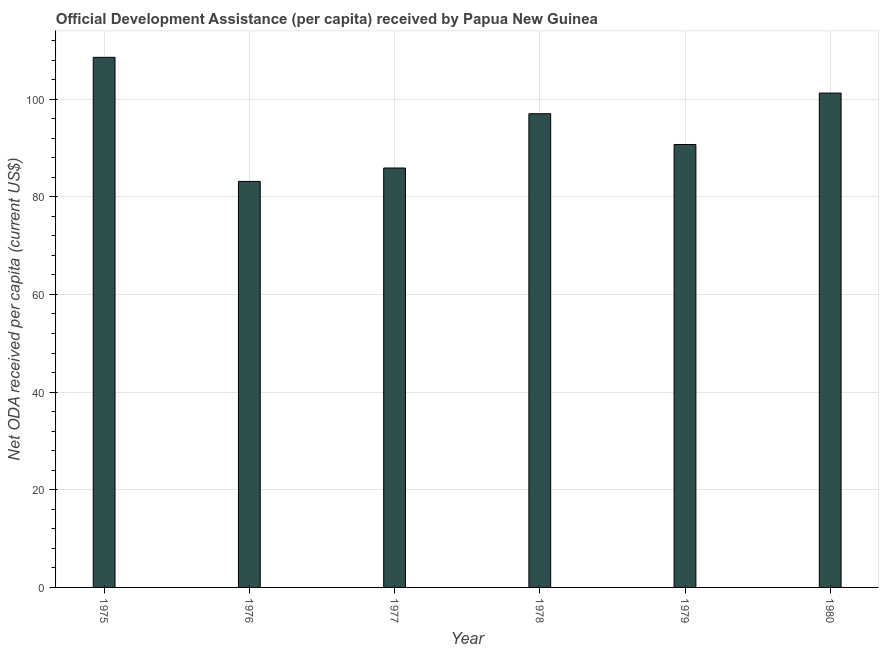Does the graph contain grids?
Make the answer very short. Yes. What is the title of the graph?
Offer a terse response. Official Development Assistance (per capita) received by Papua New Guinea. What is the label or title of the Y-axis?
Provide a succinct answer. Net ODA received per capita (current US$). What is the net oda received per capita in 1977?
Your answer should be very brief. 85.89. Across all years, what is the maximum net oda received per capita?
Provide a succinct answer. 108.56. Across all years, what is the minimum net oda received per capita?
Offer a very short reply. 83.14. In which year was the net oda received per capita maximum?
Provide a succinct answer. 1975. In which year was the net oda received per capita minimum?
Ensure brevity in your answer.  1976. What is the sum of the net oda received per capita?
Provide a succinct answer. 566.54. What is the difference between the net oda received per capita in 1976 and 1977?
Your answer should be very brief. -2.75. What is the average net oda received per capita per year?
Make the answer very short. 94.42. What is the median net oda received per capita?
Your response must be concise. 93.86. In how many years, is the net oda received per capita greater than 56 US$?
Your answer should be very brief. 6. What is the ratio of the net oda received per capita in 1976 to that in 1977?
Give a very brief answer. 0.97. Is the net oda received per capita in 1977 less than that in 1980?
Your answer should be very brief. Yes. Is the difference between the net oda received per capita in 1976 and 1978 greater than the difference between any two years?
Provide a succinct answer. No. What is the difference between the highest and the second highest net oda received per capita?
Give a very brief answer. 7.32. What is the difference between the highest and the lowest net oda received per capita?
Provide a short and direct response. 25.41. In how many years, is the net oda received per capita greater than the average net oda received per capita taken over all years?
Your answer should be compact. 3. What is the Net ODA received per capita (current US$) in 1975?
Offer a very short reply. 108.56. What is the Net ODA received per capita (current US$) in 1976?
Keep it short and to the point. 83.14. What is the Net ODA received per capita (current US$) of 1977?
Offer a terse response. 85.89. What is the Net ODA received per capita (current US$) in 1978?
Ensure brevity in your answer.  97.01. What is the Net ODA received per capita (current US$) in 1979?
Keep it short and to the point. 90.71. What is the Net ODA received per capita (current US$) in 1980?
Your answer should be very brief. 101.24. What is the difference between the Net ODA received per capita (current US$) in 1975 and 1976?
Offer a terse response. 25.41. What is the difference between the Net ODA received per capita (current US$) in 1975 and 1977?
Your response must be concise. 22.67. What is the difference between the Net ODA received per capita (current US$) in 1975 and 1978?
Offer a terse response. 11.55. What is the difference between the Net ODA received per capita (current US$) in 1975 and 1979?
Make the answer very short. 17.85. What is the difference between the Net ODA received per capita (current US$) in 1975 and 1980?
Offer a very short reply. 7.32. What is the difference between the Net ODA received per capita (current US$) in 1976 and 1977?
Ensure brevity in your answer.  -2.75. What is the difference between the Net ODA received per capita (current US$) in 1976 and 1978?
Your response must be concise. -13.87. What is the difference between the Net ODA received per capita (current US$) in 1976 and 1979?
Provide a succinct answer. -7.56. What is the difference between the Net ODA received per capita (current US$) in 1976 and 1980?
Your answer should be compact. -18.1. What is the difference between the Net ODA received per capita (current US$) in 1977 and 1978?
Offer a very short reply. -11.12. What is the difference between the Net ODA received per capita (current US$) in 1977 and 1979?
Make the answer very short. -4.82. What is the difference between the Net ODA received per capita (current US$) in 1977 and 1980?
Offer a very short reply. -15.35. What is the difference between the Net ODA received per capita (current US$) in 1978 and 1979?
Your answer should be very brief. 6.3. What is the difference between the Net ODA received per capita (current US$) in 1978 and 1980?
Provide a short and direct response. -4.23. What is the difference between the Net ODA received per capita (current US$) in 1979 and 1980?
Your answer should be compact. -10.53. What is the ratio of the Net ODA received per capita (current US$) in 1975 to that in 1976?
Provide a succinct answer. 1.31. What is the ratio of the Net ODA received per capita (current US$) in 1975 to that in 1977?
Provide a short and direct response. 1.26. What is the ratio of the Net ODA received per capita (current US$) in 1975 to that in 1978?
Your answer should be very brief. 1.12. What is the ratio of the Net ODA received per capita (current US$) in 1975 to that in 1979?
Your answer should be compact. 1.2. What is the ratio of the Net ODA received per capita (current US$) in 1975 to that in 1980?
Make the answer very short. 1.07. What is the ratio of the Net ODA received per capita (current US$) in 1976 to that in 1978?
Offer a terse response. 0.86. What is the ratio of the Net ODA received per capita (current US$) in 1976 to that in 1979?
Your answer should be very brief. 0.92. What is the ratio of the Net ODA received per capita (current US$) in 1976 to that in 1980?
Give a very brief answer. 0.82. What is the ratio of the Net ODA received per capita (current US$) in 1977 to that in 1978?
Keep it short and to the point. 0.89. What is the ratio of the Net ODA received per capita (current US$) in 1977 to that in 1979?
Give a very brief answer. 0.95. What is the ratio of the Net ODA received per capita (current US$) in 1977 to that in 1980?
Your answer should be very brief. 0.85. What is the ratio of the Net ODA received per capita (current US$) in 1978 to that in 1979?
Offer a terse response. 1.07. What is the ratio of the Net ODA received per capita (current US$) in 1978 to that in 1980?
Offer a terse response. 0.96. What is the ratio of the Net ODA received per capita (current US$) in 1979 to that in 1980?
Your answer should be compact. 0.9. 